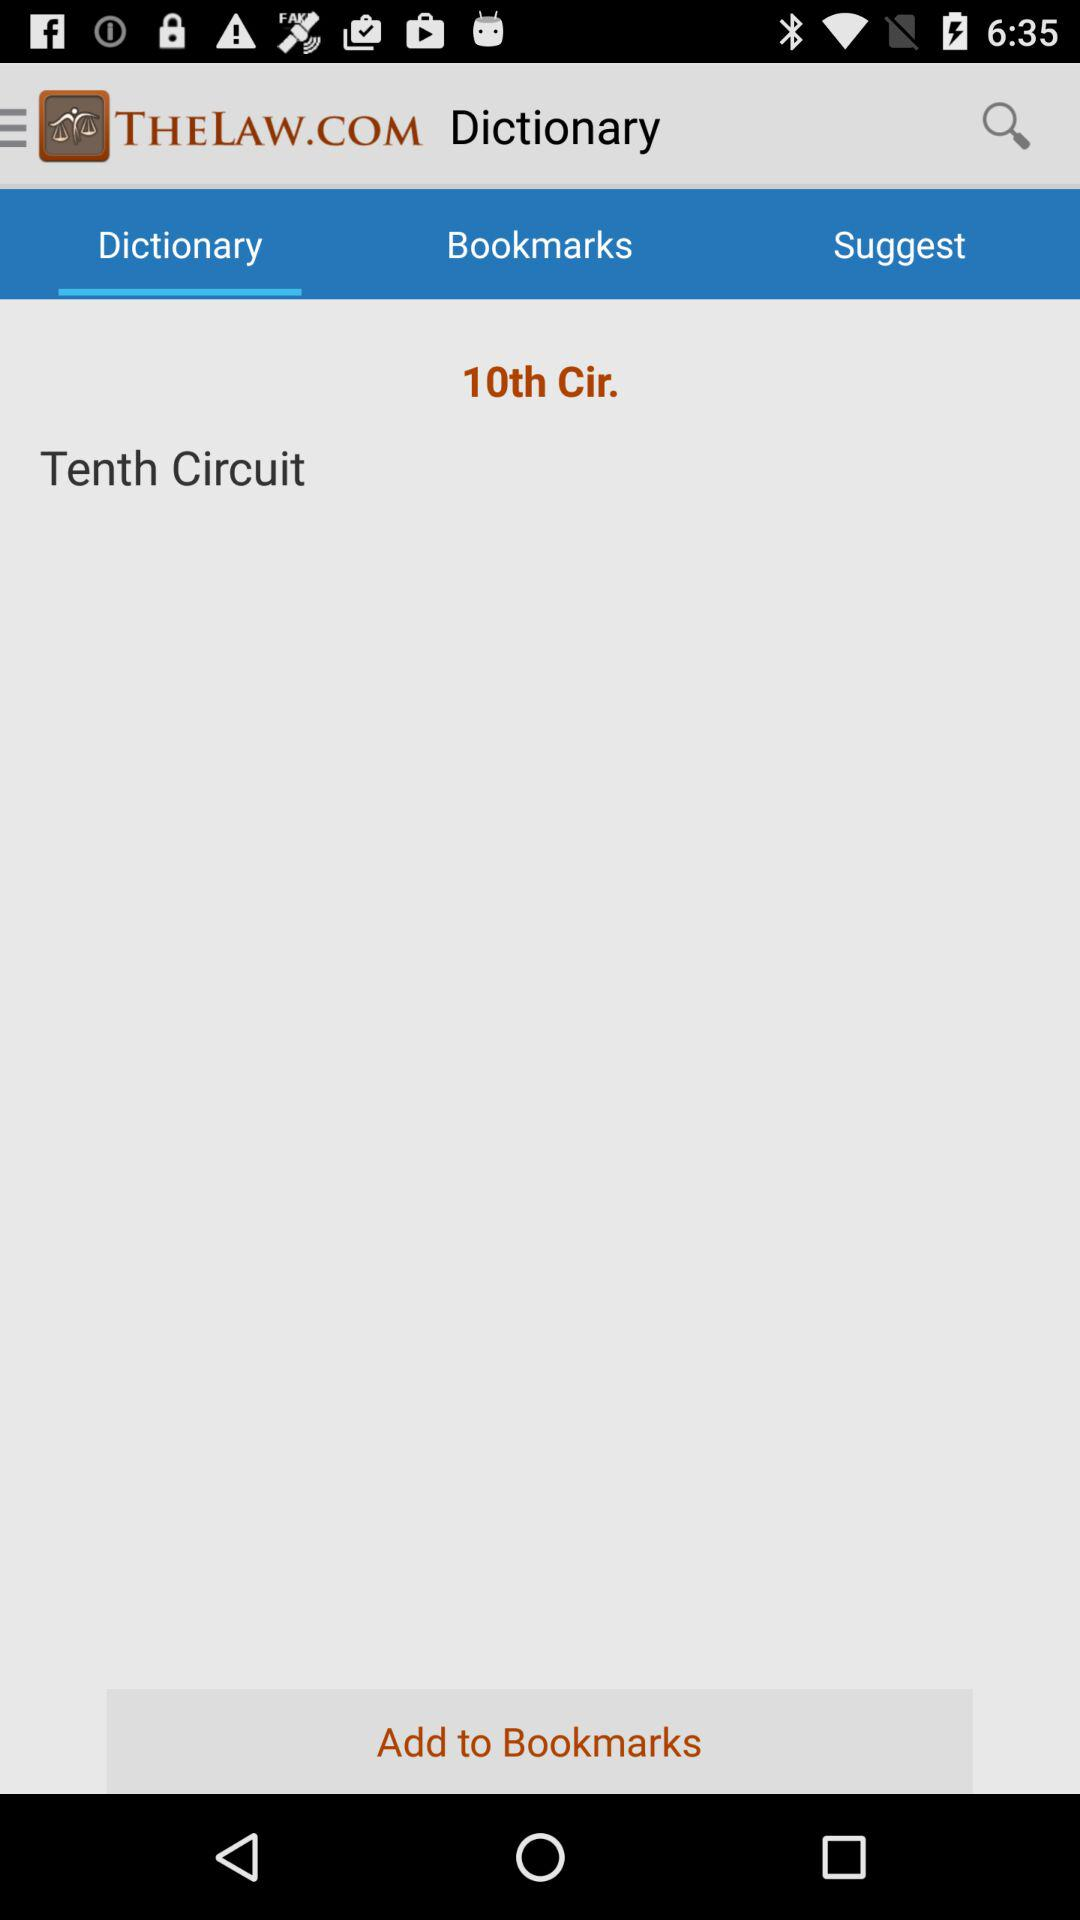Can you tell me more about what '10th Cir.' could mean? '10th Cir.' is an abbreviation for the Tenth Circuit Court of Appeals, one of the 13 federal appellate courts in the United States. It has jurisdiction over federal cases originating in six states: Colorado, Kansas, New Mexico, Oklahoma, Utah, and Wyoming.  What type of cases might be heard in the Tenth Circuit court? The Tenth Circuit Court of Appeals hears a variety of cases, including those involving federal laws, disputes between states, or constitutional issues. It's an appellate court, meaning it reviews decisions made by lower courts to ensure they adhere to legal principles and precedents. 